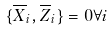<formula> <loc_0><loc_0><loc_500><loc_500>\{ \overline { X } _ { i } , \overline { Z } _ { i } \} = 0 \forall i</formula> 